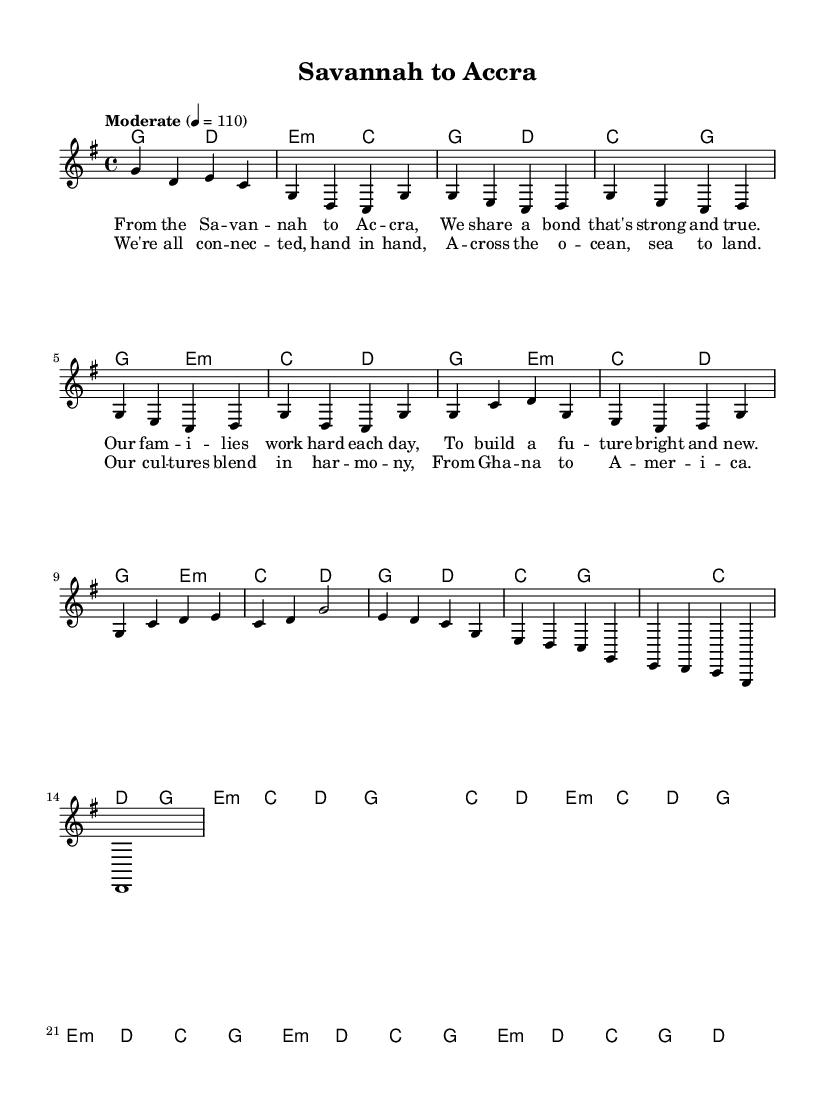What is the key signature of this music? The key signature is G major, which has one sharp (F sharp) indicated at the beginning of the staff.
Answer: G major What is the time signature of this music? The time signature is 4/4, meaning there are four beats in each measure and the quarter note gets one beat.
Answer: 4/4 What is the tempo marking for this piece? The tempo marking indicates "Moderate" with a metronome setting of 110 beats per minute, suggesting a moderate and steady pace.
Answer: Moderate 4 = 110 How many measures are in the chorus section? The chorus section consists of a total of four measures, as seen where the melody repeats combined with the chord changes.
Answer: 4 In which part do we find the lyrics "We're all connected, hand in hand"? This line is found in the chorus section of the lyrics, as it captures the essence of cultural connectivity across continents.
Answer: Chorus What is the relationship of the bridge to the verse in this piece? The bridge contrasts the verse by using different musical material while still maintaining harmonic relationships, showing a shift in dynamics and emotional expression.
Answer: Contrast Which musical element signifies the connection between Ghana and America in this piece? The recurring themes and lyrics highlight the cultural connection, emphasizing family and shared experiences bridging both nations.
Answer: Cultural connection 